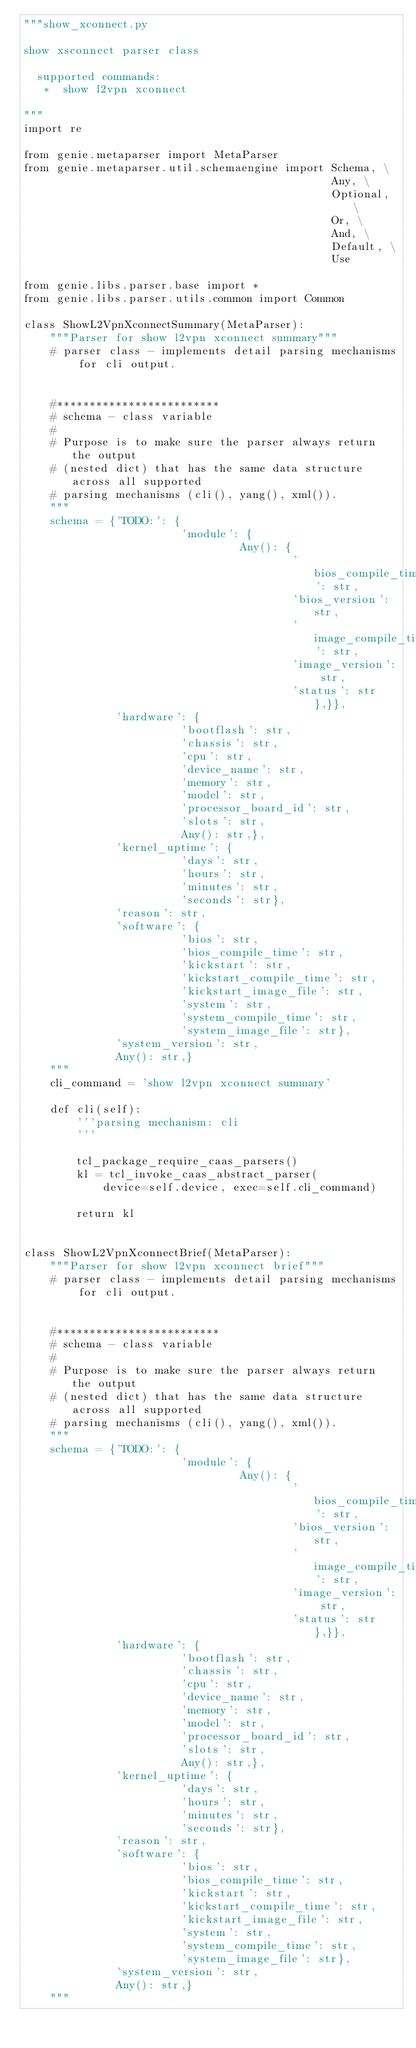Convert code to text. <code><loc_0><loc_0><loc_500><loc_500><_Python_>"""show_xconnect.py

show xsconnect parser class

  supported commands:
   *  show l2vpn xconnect
   
"""
import re

from genie.metaparser import MetaParser
from genie.metaparser.util.schemaengine import Schema, \
                                               Any, \
                                               Optional, \
                                               Or, \
                                               And, \
                                               Default, \
                                               Use

from genie.libs.parser.base import *
from genie.libs.parser.utils.common import Common

class ShowL2VpnXconnectSummary(MetaParser):
    """Parser for show l2vpn xconnect summary"""
    # parser class - implements detail parsing mechanisms for cli output.


    #*************************
    # schema - class variable
    #
    # Purpose is to make sure the parser always return the output
    # (nested dict) that has the same data structure across all supported
    # parsing mechanisms (cli(), yang(), xml()).
    """
    schema = {'TODO:': {
                        'module': {
                                 Any(): {
                                         'bios_compile_time': str,
                                         'bios_version': str,
                                         'image_compile_time': str,
                                         'image_version': str,
                                         'status': str},}},
              'hardware': {
                        'bootflash': str,
                        'chassis': str,
                        'cpu': str,
                        'device_name': str,
                        'memory': str,
                        'model': str,
                        'processor_board_id': str,
                        'slots': str,
                        Any(): str,},
              'kernel_uptime': {
                        'days': str,
                        'hours': str,
                        'minutes': str,
                        'seconds': str},
              'reason': str,
              'software': {
                        'bios': str,
                        'bios_compile_time': str,
                        'kickstart': str,
                        'kickstart_compile_time': str,
                        'kickstart_image_file': str,
                        'system': str,
                        'system_compile_time': str,
                        'system_image_file': str},
              'system_version': str,
              Any(): str,}
    """
    cli_command = 'show l2vpn xconnect summary'

    def cli(self):
        '''parsing mechanism: cli
        '''

        tcl_package_require_caas_parsers()
        kl = tcl_invoke_caas_abstract_parser(
            device=self.device, exec=self.cli_command)

        return kl


class ShowL2VpnXconnectBrief(MetaParser):
    """Parser for show l2vpn xconnect brief"""
    # parser class - implements detail parsing mechanisms for cli output.


    #*************************
    # schema - class variable
    #
    # Purpose is to make sure the parser always return the output
    # (nested dict) that has the same data structure across all supported
    # parsing mechanisms (cli(), yang(), xml()).
    """
    schema = {'TODO:': {
                        'module': {
                                 Any(): {
                                         'bios_compile_time': str,
                                         'bios_version': str,
                                         'image_compile_time': str,
                                         'image_version': str,
                                         'status': str},}},
              'hardware': {
                        'bootflash': str,
                        'chassis': str,
                        'cpu': str,
                        'device_name': str,
                        'memory': str,
                        'model': str,
                        'processor_board_id': str,
                        'slots': str,
                        Any(): str,},
              'kernel_uptime': {
                        'days': str,
                        'hours': str,
                        'minutes': str,
                        'seconds': str},
              'reason': str,
              'software': {
                        'bios': str,
                        'bios_compile_time': str,
                        'kickstart': str,
                        'kickstart_compile_time': str,
                        'kickstart_image_file': str,
                        'system': str,
                        'system_compile_time': str,
                        'system_image_file': str},
              'system_version': str,
              Any(): str,}
    """</code> 